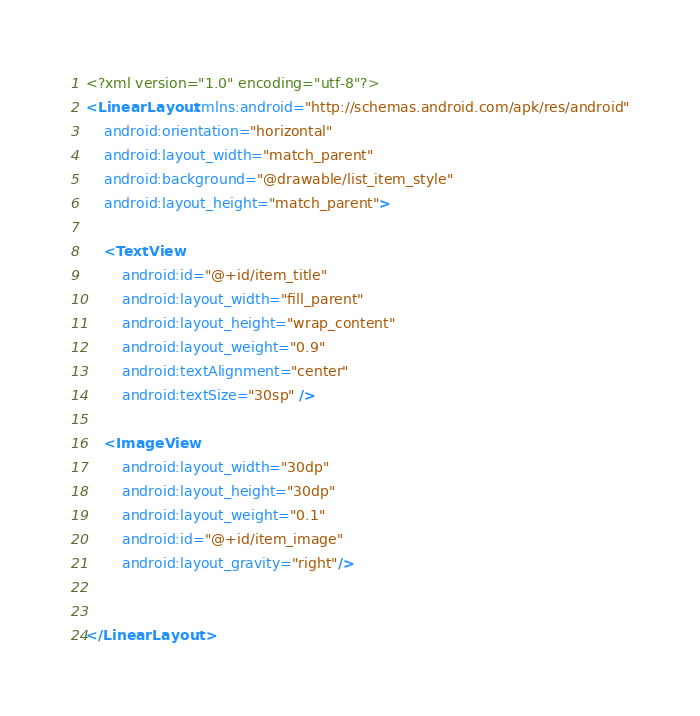Convert code to text. <code><loc_0><loc_0><loc_500><loc_500><_XML_><?xml version="1.0" encoding="utf-8"?>
<LinearLayout xmlns:android="http://schemas.android.com/apk/res/android"
    android:orientation="horizontal"
    android:layout_width="match_parent"
    android:background="@drawable/list_item_style"
    android:layout_height="match_parent">

    <TextView
        android:id="@+id/item_title"
        android:layout_width="fill_parent"
        android:layout_height="wrap_content"
        android:layout_weight="0.9"
        android:textAlignment="center"
        android:textSize="30sp" />

    <ImageView
        android:layout_width="30dp"
        android:layout_height="30dp"
        android:layout_weight="0.1"
        android:id="@+id/item_image"
        android:layout_gravity="right"/>


</LinearLayout></code> 